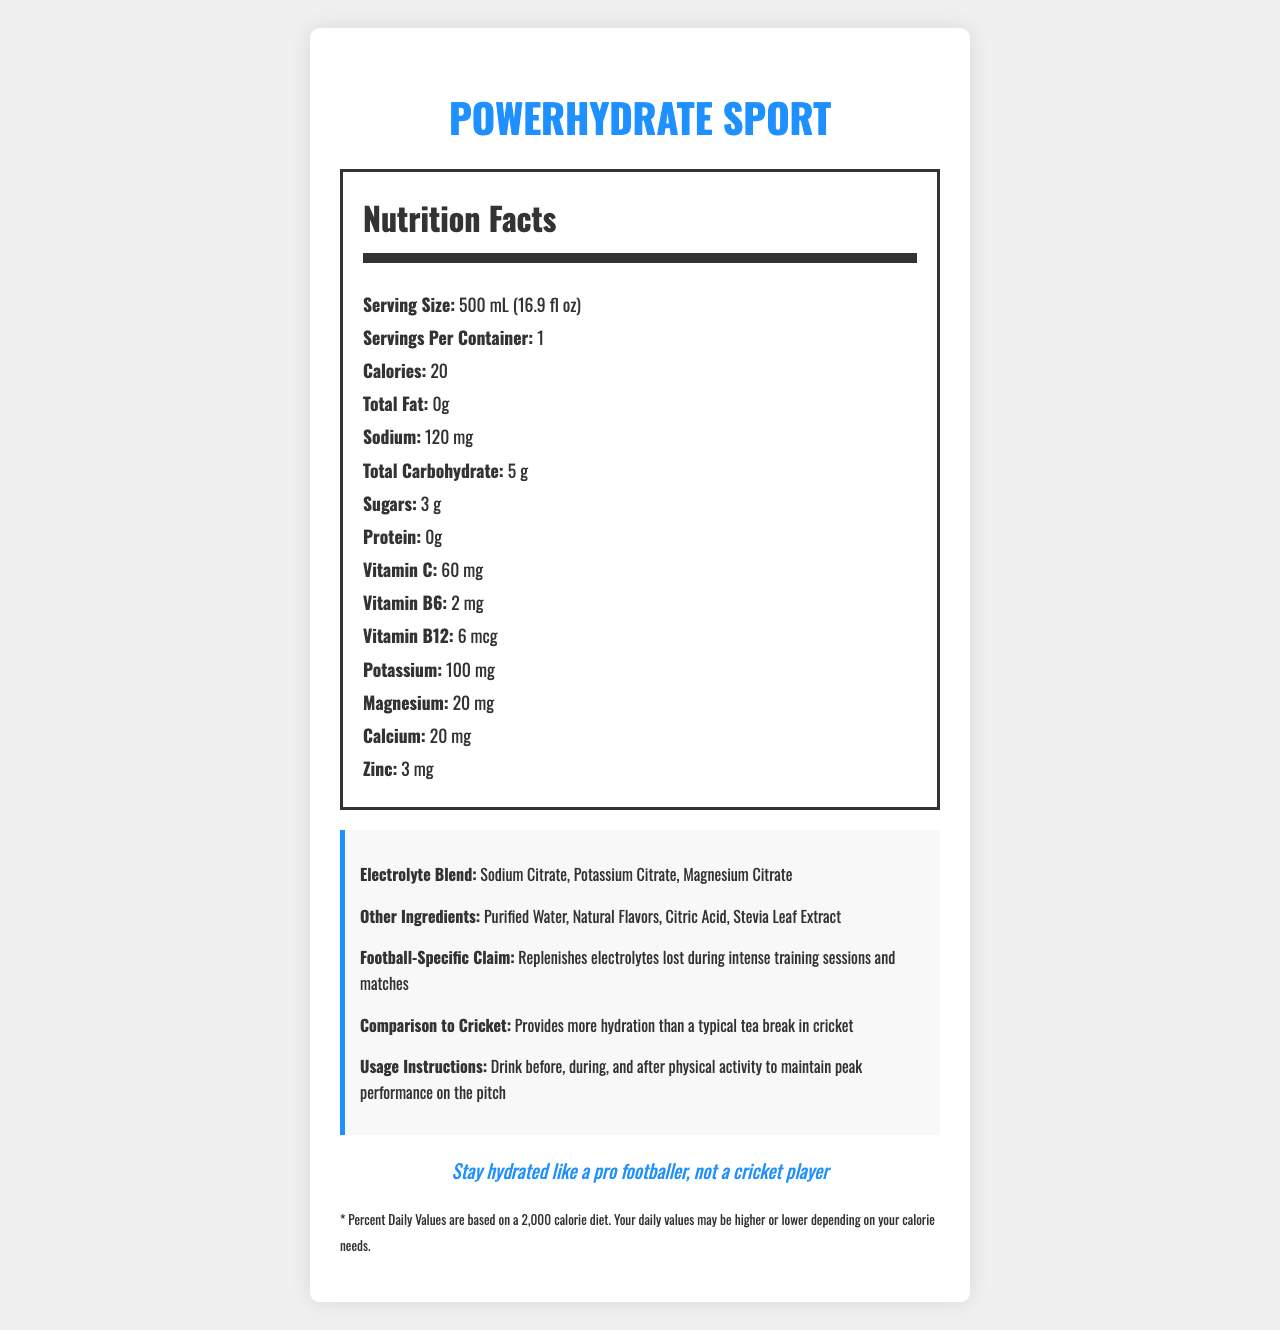what is the serving size of PowerHydrate Sport? The serving size is specified as "500 mL (16.9 fl oz)" in the nutrition facts section of the document.
Answer: 500 mL (16.9 fl oz) how many calories are in one serving of PowerHydrate Sport? The document lists the calorie content as "20" in the nutrition facts section.
Answer: 20 what is the amount of sodium per serving? The sodium content per serving is stated as "120 mg" in the nutrition facts section.
Answer: 120 mg what is the total carbohydrate content in PowerHydrate Sport? The total carbohydrate content is listed as "5 g" in the nutrition facts section.
Answer: 5 g what vitamins are included in PowerHydrate Sport? The vitamins listed in the document are "Vitamin C: 60 mg", "Vitamin B6: 2 mg", and "Vitamin B12: 6 mcg".
Answer: Vitamin C, Vitamin B6, Vitamin B12 which of the following minerals is NOT found in PowerHydrate Sport? A. Zinc B. Iron C. Calcium D. Potassium The document lists zinc, calcium, and potassium but does not mention iron.
Answer: B. Iron how many servings are in one container of PowerHydrate Sport? A. 1 B. 2 C. 3 D. 4 Each container has 1 serving as noted in the document.
Answer: A. 1 what claim does PowerHydrate Sport make specifically for football? The document mentions, "Replenishes electrolytes lost during intense training sessions and matches" under the football-specific claim section.
Answer: Replenishes electrolytes lost during intense training sessions and matches does PowerHydrate Sport contain protein? The document lists the protein content as "0 g," indicating it contains no protein.
Answer: No what is the marketing tagline for PowerHydrate Sport? The tagline is found at the bottom of the document: "Stay hydrated like a pro footballer, not a cricket player."
Answer: Stay hydrated like a pro footballer, not a cricket player provide a summary of the PowerHydrate Sport Nutrition Facts Label The summary encapsulates all key points, including nutritional content, specific marketing claims, and the overall purpose of the product.
Answer: PowerHydrate Sport is a vitamin-fortified hydration solution for active individuals, specifically marketed to football players. Each 500 mL serving contains 20 calories, 0 g total fat, 120 mg sodium, 5 g total carbohydrate (including 3 g sugars), and 0 g protein. It also includes vitamin C (60 mg), vitamin B6 (2 mg), vitamin B12 (6 mcg), potassium (100 mg), magnesium (20 mg), calcium (20 mg), and zinc (3 mg). The electrolyte blend consists of sodium citrate, potassium citrate, and magnesium citrate. The product promises to replenish electrolytes lost during intense training sessions and matches and boasts better hydration than a typical tea break in cricket. is PowerHydrate Sport aimed at providing better hydration than a cricket tea break? The document explicitly mentions, "Provides more hydration than a typical tea break in cricket."
Answer: Yes what is the company's annual revenue from PowerHydrate Sport? The document does not provide any information about the company's revenue.
Answer: Cannot be determined what is the primary flavoring method for PowerHydrate Sport? The "Other Ingredients" section lists "Natural Flavors" as one of the main flavoring methods.
Answer: Natural Flavors 